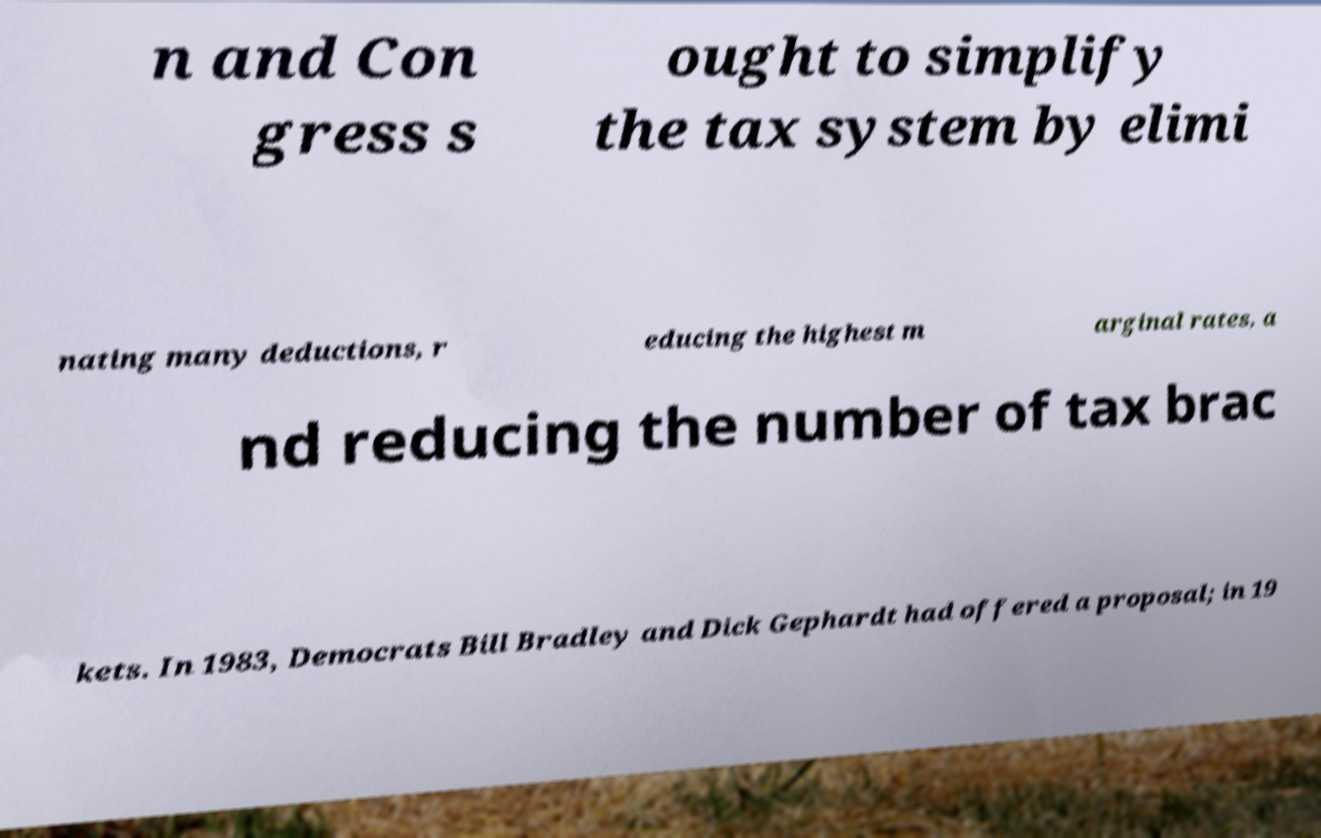Please read and relay the text visible in this image. What does it say? n and Con gress s ought to simplify the tax system by elimi nating many deductions, r educing the highest m arginal rates, a nd reducing the number of tax brac kets. In 1983, Democrats Bill Bradley and Dick Gephardt had offered a proposal; in 19 